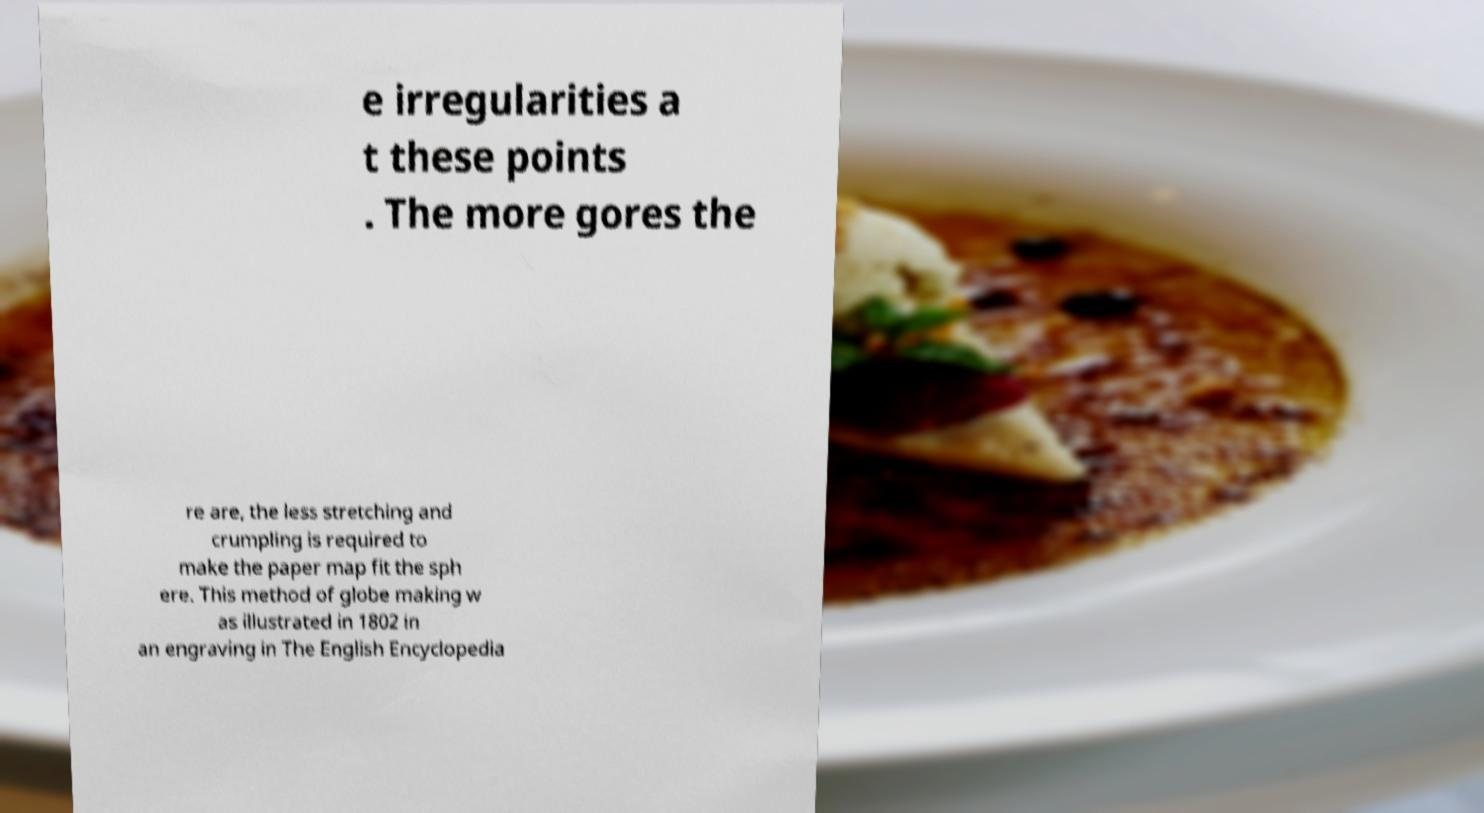Please read and relay the text visible in this image. What does it say? e irregularities a t these points . The more gores the re are, the less stretching and crumpling is required to make the paper map fit the sph ere. This method of globe making w as illustrated in 1802 in an engraving in The English Encyclopedia 